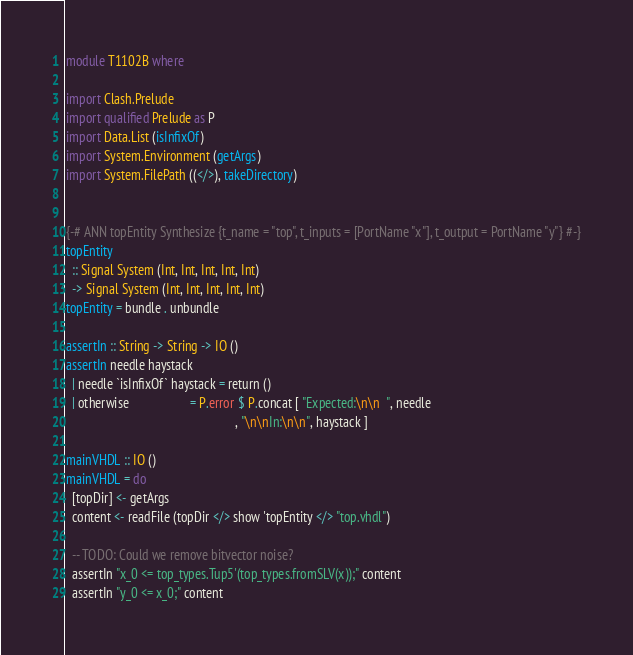Convert code to text. <code><loc_0><loc_0><loc_500><loc_500><_Haskell_>module T1102B where

import Clash.Prelude
import qualified Prelude as P
import Data.List (isInfixOf)
import System.Environment (getArgs)
import System.FilePath ((</>), takeDirectory)


{-# ANN topEntity Synthesize {t_name = "top", t_inputs = [PortName "x"], t_output = PortName "y"} #-}
topEntity
  :: Signal System (Int, Int, Int, Int, Int)
  -> Signal System (Int, Int, Int, Int, Int)
topEntity = bundle . unbundle

assertIn :: String -> String -> IO ()
assertIn needle haystack
  | needle `isInfixOf` haystack = return ()
  | otherwise                   = P.error $ P.concat [ "Expected:\n\n  ", needle
                                                     , "\n\nIn:\n\n", haystack ]

mainVHDL :: IO ()
mainVHDL = do
  [topDir] <- getArgs
  content <- readFile (topDir </> show 'topEntity </> "top.vhdl")

  -- TODO: Could we remove bitvector noise?
  assertIn "x_0 <= top_types.Tup5'(top_types.fromSLV(x));" content
  assertIn "y_0 <= x_0;" content
</code> 